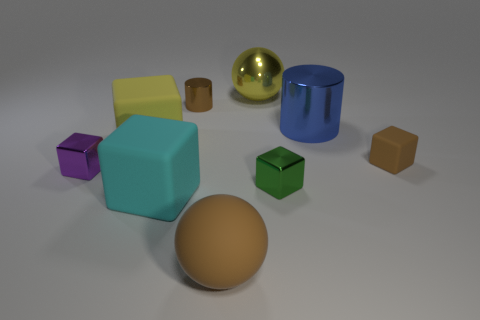Is the blue thing the same shape as the big brown thing?
Keep it short and to the point. No. Is there any other thing that has the same shape as the large blue metallic object?
Provide a succinct answer. Yes. Do the cylinder that is left of the large brown matte ball and the rubber thing behind the small matte cube have the same color?
Make the answer very short. No. Are there fewer large blue cylinders that are left of the big rubber sphere than metal cylinders that are on the right side of the big yellow ball?
Make the answer very short. Yes. There is a yellow thing to the right of the large brown thing; what is its shape?
Your answer should be compact. Sphere. What material is the cylinder that is the same color as the big rubber sphere?
Offer a terse response. Metal. What number of other objects are there of the same material as the large cyan object?
Your response must be concise. 3. Do the tiny brown rubber object and the shiny object that is on the left side of the small shiny cylinder have the same shape?
Provide a succinct answer. Yes. There is a yellow object that is the same material as the big brown thing; what is its shape?
Provide a short and direct response. Cube. Are there more big rubber blocks that are behind the purple metallic block than big rubber things in front of the cyan matte cube?
Ensure brevity in your answer.  No. 